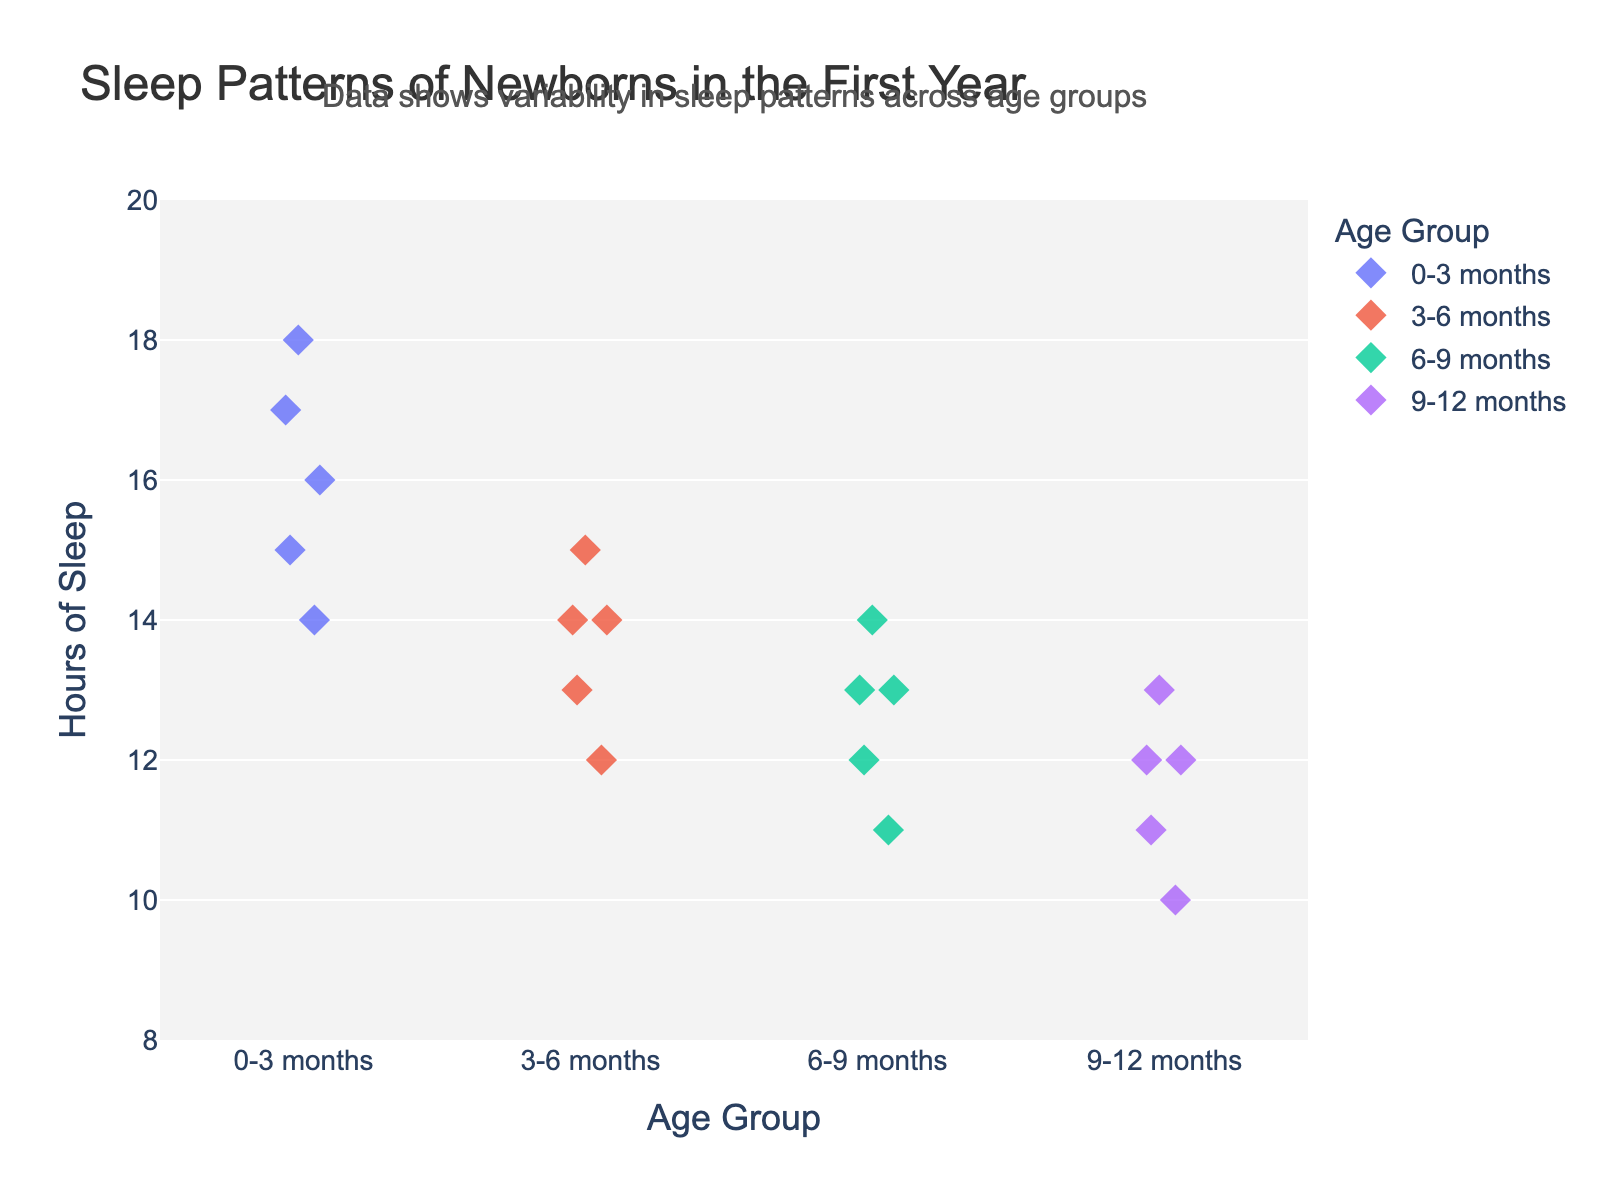what is the title of the plot? The title is displayed at the top of the plot.
Answer: Sleep Patterns of Newborns in the First Year how many age groups are represented in the plot? Look along the x-axis for unique categories.
Answer: 4 which age group has the highest recorded hours of sleep? Identify the highest data point along the y-axis and note the corresponding age group.
Answer: 0-3 months what is the lowest number of hours of sleep recorded across all age groups? Identify the smallest data point on the y-axis.
Answer: 10 on average, how many hours of sleep do babies get in the 9-12 months age group? Add the sleep hours for all babies in the 9-12 months category and divide by the number of data points (5). Calculation: (12 + 11 + 13 + 10 + 12) / 5.
Answer: 11.6 how do the sleep patterns of babies aged 3-6 months compare to those aged 6-9 months? Compare the range and distribution of data points between the two age groups along the y-axis.
Answer: Hours of sleep for 3-6 months range from 12 to 15, while for 6-9 months it's from 11 to 14 what is the difference in maximum hours of sleep between the 0-3 months and 9-12 months age groups? Identify the maximum values for both age groups along the y-axis and subtract the 9-12 months maximum from the 0-3 months maximum. Calculation: 18 (0-3 months) - 13 (9-12 months).
Answer: 5 which age group has the most uniform sleep pattern? Observe which group has the least spread in the data points along the y-axis.
Answer: 3-6 months 